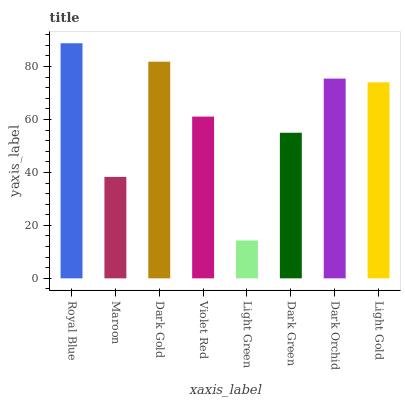Is Light Green the minimum?
Answer yes or no. Yes. Is Royal Blue the maximum?
Answer yes or no. Yes. Is Maroon the minimum?
Answer yes or no. No. Is Maroon the maximum?
Answer yes or no. No. Is Royal Blue greater than Maroon?
Answer yes or no. Yes. Is Maroon less than Royal Blue?
Answer yes or no. Yes. Is Maroon greater than Royal Blue?
Answer yes or no. No. Is Royal Blue less than Maroon?
Answer yes or no. No. Is Light Gold the high median?
Answer yes or no. Yes. Is Violet Red the low median?
Answer yes or no. Yes. Is Royal Blue the high median?
Answer yes or no. No. Is Dark Green the low median?
Answer yes or no. No. 